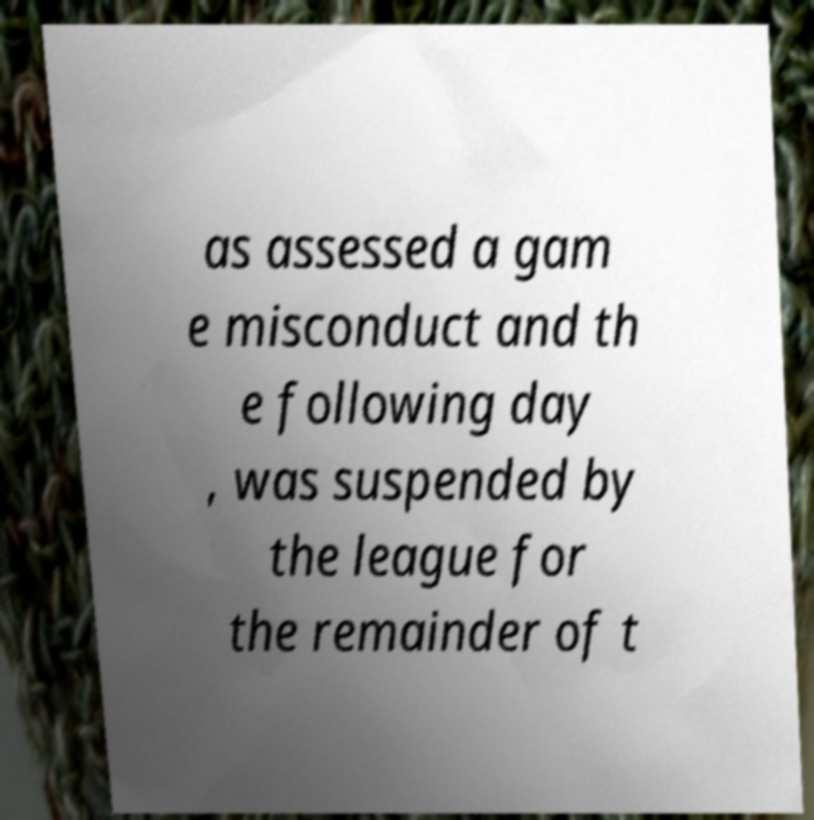There's text embedded in this image that I need extracted. Can you transcribe it verbatim? as assessed a gam e misconduct and th e following day , was suspended by the league for the remainder of t 